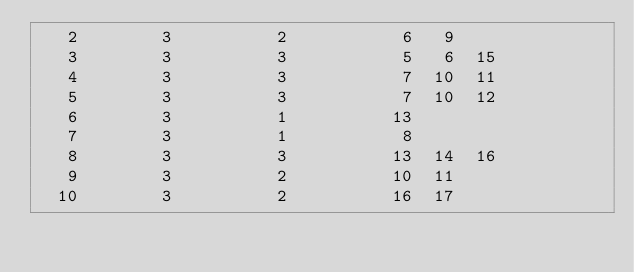<code> <loc_0><loc_0><loc_500><loc_500><_ObjectiveC_>   2        3          2           6   9
   3        3          3           5   6  15
   4        3          3           7  10  11
   5        3          3           7  10  12
   6        3          1          13
   7        3          1           8
   8        3          3          13  14  16
   9        3          2          10  11
  10        3          2          16  17</code> 